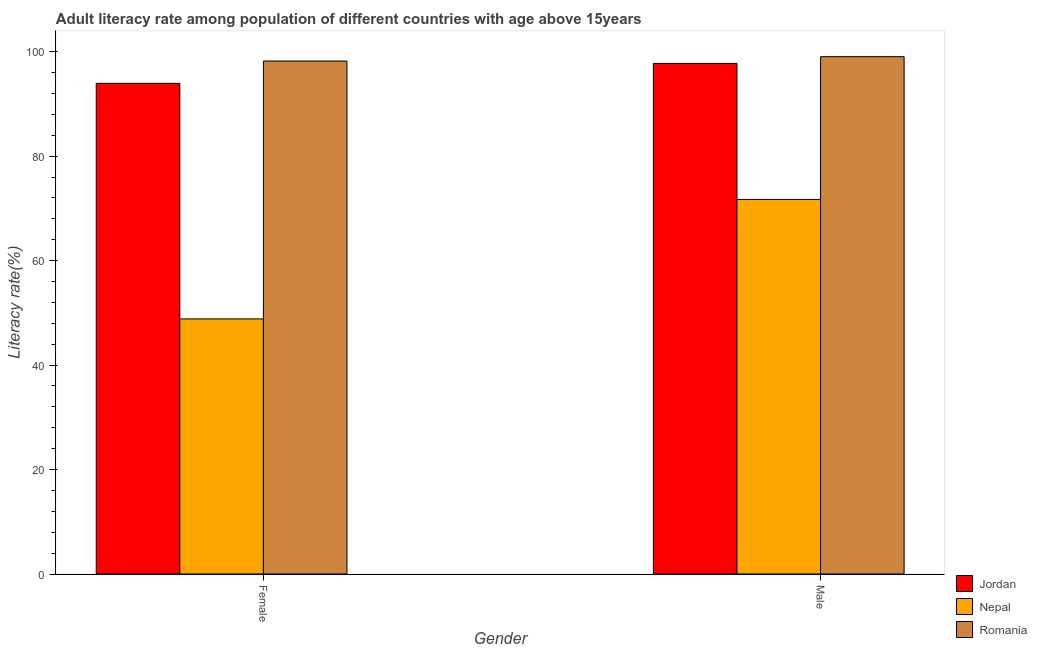How many groups of bars are there?
Your response must be concise. 2. How many bars are there on the 2nd tick from the right?
Give a very brief answer. 3. What is the label of the 2nd group of bars from the left?
Offer a terse response. Male. What is the female adult literacy rate in Romania?
Make the answer very short. 98.21. Across all countries, what is the maximum male adult literacy rate?
Keep it short and to the point. 99.03. Across all countries, what is the minimum female adult literacy rate?
Your response must be concise. 48.84. In which country was the female adult literacy rate maximum?
Your response must be concise. Romania. In which country was the female adult literacy rate minimum?
Keep it short and to the point. Nepal. What is the total male adult literacy rate in the graph?
Provide a short and direct response. 268.49. What is the difference between the male adult literacy rate in Jordan and that in Romania?
Your answer should be very brief. -1.29. What is the difference between the female adult literacy rate in Romania and the male adult literacy rate in Jordan?
Your answer should be compact. 0.46. What is the average male adult literacy rate per country?
Your response must be concise. 89.5. What is the difference between the female adult literacy rate and male adult literacy rate in Romania?
Give a very brief answer. -0.83. In how many countries, is the female adult literacy rate greater than 80 %?
Your response must be concise. 2. What is the ratio of the male adult literacy rate in Nepal to that in Romania?
Provide a short and direct response. 0.72. What does the 1st bar from the left in Male represents?
Make the answer very short. Jordan. What does the 3rd bar from the right in Female represents?
Give a very brief answer. Jordan. Are all the bars in the graph horizontal?
Keep it short and to the point. No. Does the graph contain any zero values?
Your response must be concise. No. What is the title of the graph?
Offer a very short reply. Adult literacy rate among population of different countries with age above 15years. What is the label or title of the X-axis?
Provide a short and direct response. Gender. What is the label or title of the Y-axis?
Offer a very short reply. Literacy rate(%). What is the Literacy rate(%) of Jordan in Female?
Your answer should be very brief. 93.93. What is the Literacy rate(%) of Nepal in Female?
Your answer should be compact. 48.84. What is the Literacy rate(%) of Romania in Female?
Make the answer very short. 98.21. What is the Literacy rate(%) in Jordan in Male?
Keep it short and to the point. 97.75. What is the Literacy rate(%) of Nepal in Male?
Ensure brevity in your answer.  71.71. What is the Literacy rate(%) of Romania in Male?
Provide a succinct answer. 99.03. Across all Gender, what is the maximum Literacy rate(%) in Jordan?
Your answer should be very brief. 97.75. Across all Gender, what is the maximum Literacy rate(%) in Nepal?
Keep it short and to the point. 71.71. Across all Gender, what is the maximum Literacy rate(%) in Romania?
Provide a succinct answer. 99.03. Across all Gender, what is the minimum Literacy rate(%) in Jordan?
Provide a succinct answer. 93.93. Across all Gender, what is the minimum Literacy rate(%) in Nepal?
Offer a terse response. 48.84. Across all Gender, what is the minimum Literacy rate(%) of Romania?
Offer a very short reply. 98.21. What is the total Literacy rate(%) in Jordan in the graph?
Your answer should be compact. 191.68. What is the total Literacy rate(%) of Nepal in the graph?
Keep it short and to the point. 120.55. What is the total Literacy rate(%) in Romania in the graph?
Give a very brief answer. 197.24. What is the difference between the Literacy rate(%) in Jordan in Female and that in Male?
Your response must be concise. -3.81. What is the difference between the Literacy rate(%) in Nepal in Female and that in Male?
Make the answer very short. -22.87. What is the difference between the Literacy rate(%) in Romania in Female and that in Male?
Provide a short and direct response. -0.83. What is the difference between the Literacy rate(%) in Jordan in Female and the Literacy rate(%) in Nepal in Male?
Make the answer very short. 22.23. What is the difference between the Literacy rate(%) of Jordan in Female and the Literacy rate(%) of Romania in Male?
Keep it short and to the point. -5.1. What is the difference between the Literacy rate(%) of Nepal in Female and the Literacy rate(%) of Romania in Male?
Keep it short and to the point. -50.2. What is the average Literacy rate(%) in Jordan per Gender?
Offer a terse response. 95.84. What is the average Literacy rate(%) of Nepal per Gender?
Offer a terse response. 60.27. What is the average Literacy rate(%) in Romania per Gender?
Make the answer very short. 98.62. What is the difference between the Literacy rate(%) in Jordan and Literacy rate(%) in Nepal in Female?
Your response must be concise. 45.1. What is the difference between the Literacy rate(%) in Jordan and Literacy rate(%) in Romania in Female?
Your answer should be compact. -4.27. What is the difference between the Literacy rate(%) of Nepal and Literacy rate(%) of Romania in Female?
Offer a very short reply. -49.37. What is the difference between the Literacy rate(%) in Jordan and Literacy rate(%) in Nepal in Male?
Provide a succinct answer. 26.04. What is the difference between the Literacy rate(%) in Jordan and Literacy rate(%) in Romania in Male?
Provide a short and direct response. -1.29. What is the difference between the Literacy rate(%) of Nepal and Literacy rate(%) of Romania in Male?
Provide a succinct answer. -27.33. What is the ratio of the Literacy rate(%) in Nepal in Female to that in Male?
Keep it short and to the point. 0.68. What is the difference between the highest and the second highest Literacy rate(%) of Jordan?
Provide a short and direct response. 3.81. What is the difference between the highest and the second highest Literacy rate(%) in Nepal?
Ensure brevity in your answer.  22.87. What is the difference between the highest and the second highest Literacy rate(%) in Romania?
Ensure brevity in your answer.  0.83. What is the difference between the highest and the lowest Literacy rate(%) in Jordan?
Your answer should be compact. 3.81. What is the difference between the highest and the lowest Literacy rate(%) in Nepal?
Keep it short and to the point. 22.87. What is the difference between the highest and the lowest Literacy rate(%) of Romania?
Your response must be concise. 0.83. 